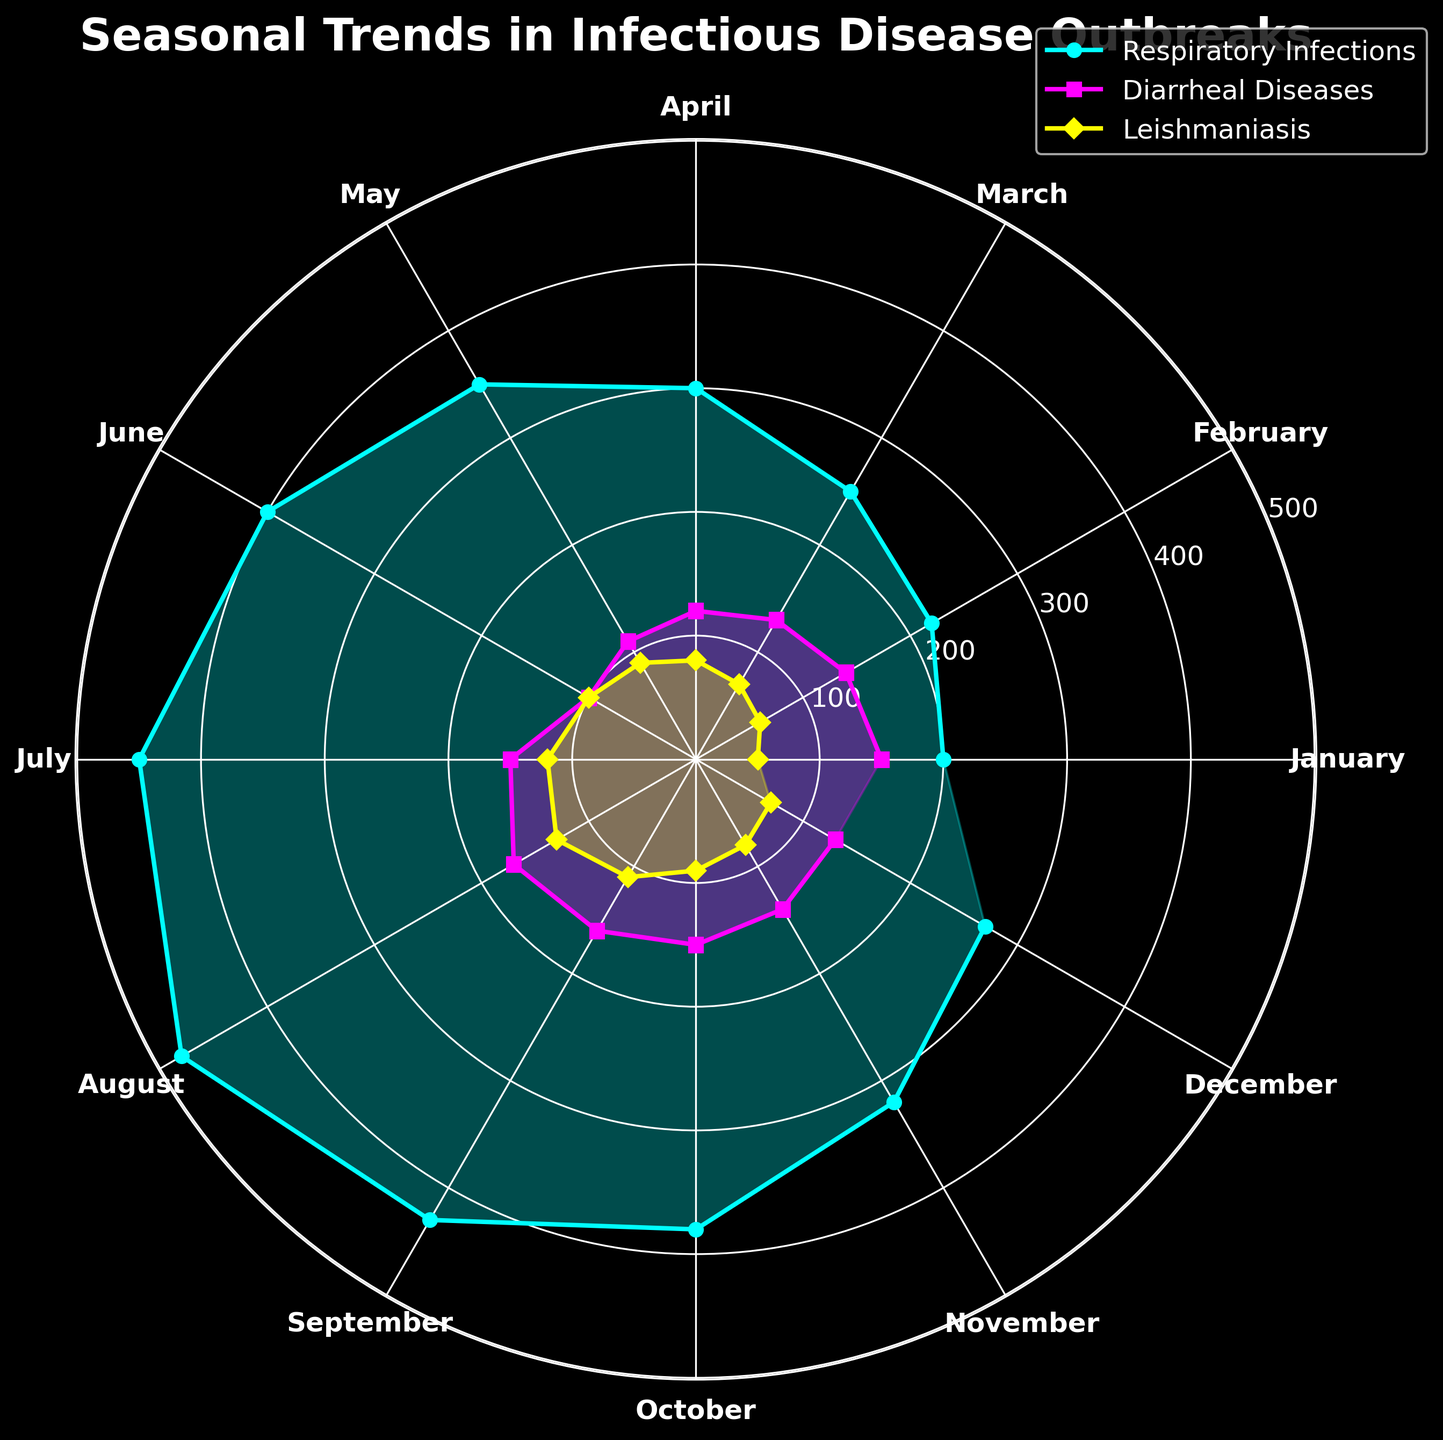Which disease had the highest number of cases in the month of July? To determine which disease had the highest number of cases in July, look at the plot for July and compare the three disease case counts. Respiratory Infections have the highest value.
Answer: Respiratory Infections Between which two months is the increase in cases of Respiratory Infections the greatest? To find this, look at the length of the plot segments for Respiratory Infections between consecutive months. The largest jump occurs between June and July.
Answer: June and July What is the total number of cases for Leishmaniasis in the first quarter (January, February, and March)? Add the number of cases for Leishmaniasis in January (50), February (60), and March (70). So, the total is 50 + 60 + 70 = 180.
Answer: 180 In which month are Diarrheal Diseases cases the highest? Examine the plot's segment for Diarrheal Diseases. The peak value is in August.
Answer: August How do the number of cases for Respiratory Infections in May compare with those in December? Compare the plot's lengths for Respiratory Infections in May and December. May has 350 cases while December has 270 cases, so May has more cases.
Answer: May has more cases What’s the trend in the number of cases for Respiratory Infections from January to August? Observe the plot for Respiratory Infections across months January to August. The number of cases consistently increases each month.
Answer: Increasing trend What's the difference between the number of cases of Diarrheal Diseases in August and September? Subtract the number of cases in September from the number in August: 170 - 160 = 10.
Answer: 10 Which disease had the most cases overall in the year, based on the plot? By identifying which disease has the longest segments overall across all months, it’s clear that Respiratory Infections always have higher values.
Answer: Respiratory Infections In which month is the difference between cases of Respiratory Infections and Diarrheal Diseases the smallest? Look for the months where the plot lines of Respiratory Infections and Diarrheal Diseases are closest. This occurs in July.
Answer: July 